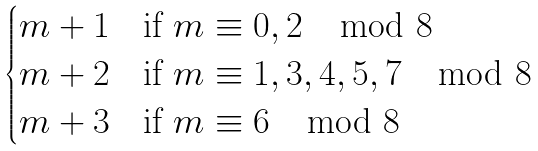Convert formula to latex. <formula><loc_0><loc_0><loc_500><loc_500>\begin{cases} m + 1 & \text {if} \ m \equiv 0 , 2 \mod 8 \\ m + 2 & \text {if} \ m \equiv 1 , 3 , 4 , 5 , 7 \mod 8 \\ m + 3 & \text {if} \ m \equiv 6 \mod 8 \end{cases}</formula> 